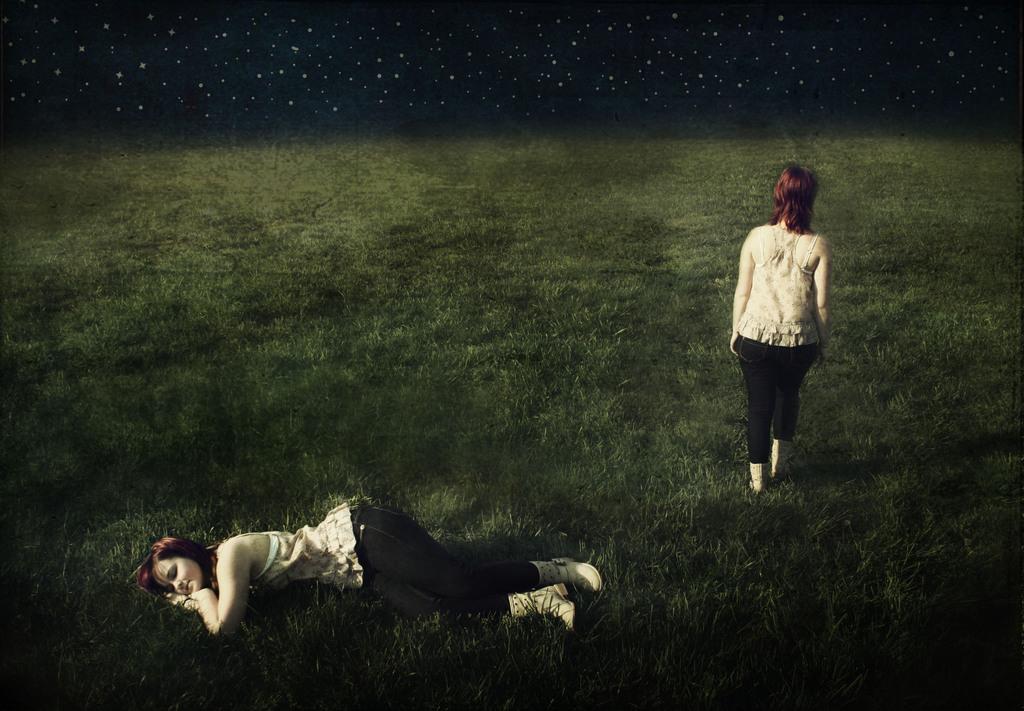Could you give a brief overview of what you see in this image? This picture shows a woman laying on the ground and we see another woman standing and we see grass on the ground. 